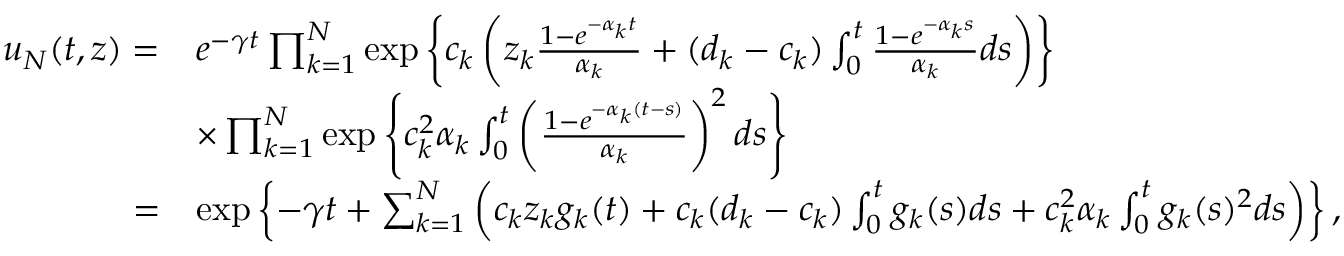<formula> <loc_0><loc_0><loc_500><loc_500>\begin{array} { r l } { u _ { N } ( t , z ) = } & { e ^ { - \gamma t } \prod _ { k = 1 } ^ { N } \exp \left \{ c _ { k } \left ( z _ { k } \frac { 1 - e ^ { - \alpha _ { k } t } } { \alpha _ { k } } + ( d _ { k } - c _ { k } ) \int _ { 0 } ^ { t } \frac { 1 - e ^ { - \alpha _ { k } s } } { \alpha _ { k } } d s \right ) \right \} } \\ & { \times \prod _ { k = 1 } ^ { N } \exp \left \{ c _ { k } ^ { 2 } \alpha _ { k } \int _ { 0 } ^ { t } \left ( \frac { 1 - e ^ { - \alpha _ { k } ( t - s ) } } { \alpha _ { k } } \right ) ^ { 2 } d s \right \} } \\ { = } & { \exp \left \{ - \gamma t + \sum _ { k = 1 } ^ { N } \left ( c _ { k } z _ { k } g _ { k } ( t ) + c _ { k } ( d _ { k } - c _ { k } ) \int _ { 0 } ^ { t } g _ { k } ( s ) d s + c _ { k } ^ { 2 } \alpha _ { k } \int _ { 0 } ^ { t } g _ { k } ( s ) ^ { 2 } d s \right ) \right \} , } \end{array}</formula> 